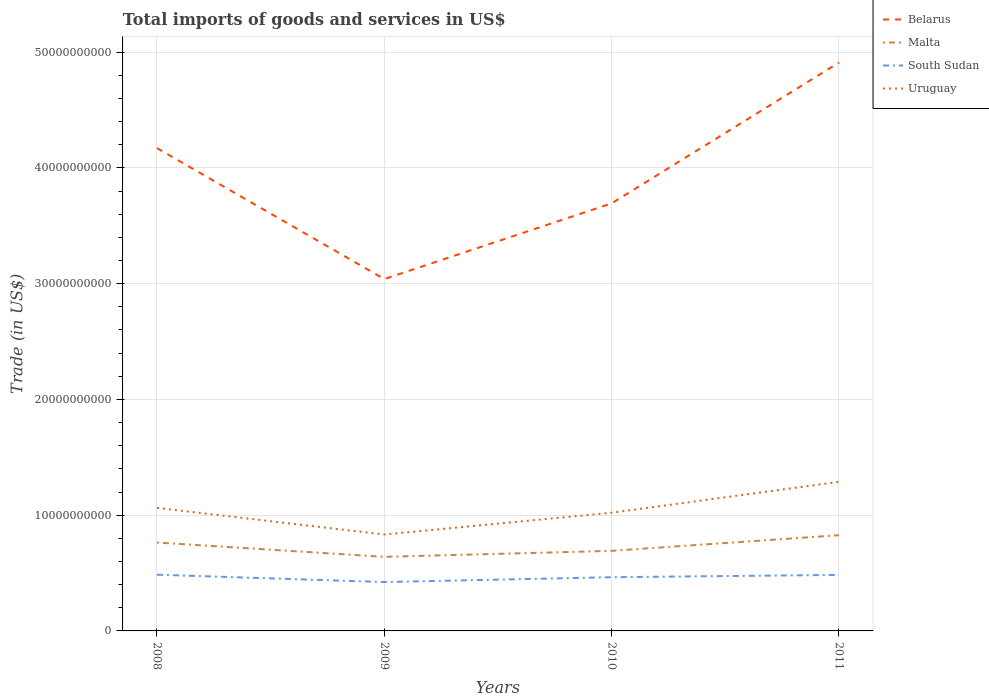How many different coloured lines are there?
Provide a short and direct response. 4. Does the line corresponding to South Sudan intersect with the line corresponding to Uruguay?
Your answer should be compact. No. Is the number of lines equal to the number of legend labels?
Keep it short and to the point. Yes. Across all years, what is the maximum total imports of goods and services in South Sudan?
Your response must be concise. 4.22e+09. What is the total total imports of goods and services in Belarus in the graph?
Offer a very short reply. 4.77e+09. What is the difference between the highest and the second highest total imports of goods and services in South Sudan?
Offer a terse response. 6.35e+08. How many years are there in the graph?
Give a very brief answer. 4. Are the values on the major ticks of Y-axis written in scientific E-notation?
Your answer should be very brief. No. Does the graph contain any zero values?
Make the answer very short. No. How many legend labels are there?
Ensure brevity in your answer.  4. What is the title of the graph?
Make the answer very short. Total imports of goods and services in US$. What is the label or title of the X-axis?
Provide a short and direct response. Years. What is the label or title of the Y-axis?
Offer a terse response. Trade (in US$). What is the Trade (in US$) of Belarus in 2008?
Give a very brief answer. 4.17e+1. What is the Trade (in US$) of Malta in 2008?
Ensure brevity in your answer.  7.64e+09. What is the Trade (in US$) in South Sudan in 2008?
Your response must be concise. 4.86e+09. What is the Trade (in US$) in Uruguay in 2008?
Give a very brief answer. 1.06e+1. What is the Trade (in US$) of Belarus in 2009?
Your answer should be very brief. 3.04e+1. What is the Trade (in US$) in Malta in 2009?
Give a very brief answer. 6.40e+09. What is the Trade (in US$) of South Sudan in 2009?
Offer a very short reply. 4.22e+09. What is the Trade (in US$) of Uruguay in 2009?
Your answer should be very brief. 8.33e+09. What is the Trade (in US$) in Belarus in 2010?
Give a very brief answer. 3.69e+1. What is the Trade (in US$) of Malta in 2010?
Your response must be concise. 6.92e+09. What is the Trade (in US$) of South Sudan in 2010?
Your answer should be very brief. 4.64e+09. What is the Trade (in US$) in Uruguay in 2010?
Provide a succinct answer. 1.02e+1. What is the Trade (in US$) of Belarus in 2011?
Provide a succinct answer. 4.91e+1. What is the Trade (in US$) in Malta in 2011?
Offer a terse response. 8.27e+09. What is the Trade (in US$) of South Sudan in 2011?
Provide a succinct answer. 4.84e+09. What is the Trade (in US$) of Uruguay in 2011?
Give a very brief answer. 1.29e+1. Across all years, what is the maximum Trade (in US$) in Belarus?
Offer a terse response. 4.91e+1. Across all years, what is the maximum Trade (in US$) of Malta?
Offer a very short reply. 8.27e+09. Across all years, what is the maximum Trade (in US$) in South Sudan?
Your response must be concise. 4.86e+09. Across all years, what is the maximum Trade (in US$) in Uruguay?
Your response must be concise. 1.29e+1. Across all years, what is the minimum Trade (in US$) of Belarus?
Give a very brief answer. 3.04e+1. Across all years, what is the minimum Trade (in US$) of Malta?
Offer a terse response. 6.40e+09. Across all years, what is the minimum Trade (in US$) of South Sudan?
Offer a terse response. 4.22e+09. Across all years, what is the minimum Trade (in US$) of Uruguay?
Keep it short and to the point. 8.33e+09. What is the total Trade (in US$) of Belarus in the graph?
Offer a terse response. 1.58e+11. What is the total Trade (in US$) in Malta in the graph?
Provide a succinct answer. 2.92e+1. What is the total Trade (in US$) of South Sudan in the graph?
Your answer should be compact. 1.86e+1. What is the total Trade (in US$) of Uruguay in the graph?
Your response must be concise. 4.21e+1. What is the difference between the Trade (in US$) in Belarus in 2008 and that in 2009?
Provide a succinct answer. 1.13e+1. What is the difference between the Trade (in US$) of Malta in 2008 and that in 2009?
Make the answer very short. 1.24e+09. What is the difference between the Trade (in US$) in South Sudan in 2008 and that in 2009?
Your response must be concise. 6.35e+08. What is the difference between the Trade (in US$) in Uruguay in 2008 and that in 2009?
Provide a succinct answer. 2.30e+09. What is the difference between the Trade (in US$) of Belarus in 2008 and that in 2010?
Keep it short and to the point. 4.77e+09. What is the difference between the Trade (in US$) in Malta in 2008 and that in 2010?
Keep it short and to the point. 7.18e+08. What is the difference between the Trade (in US$) in South Sudan in 2008 and that in 2010?
Ensure brevity in your answer.  2.17e+08. What is the difference between the Trade (in US$) in Uruguay in 2008 and that in 2010?
Your answer should be compact. 4.18e+08. What is the difference between the Trade (in US$) of Belarus in 2008 and that in 2011?
Give a very brief answer. -7.39e+09. What is the difference between the Trade (in US$) of Malta in 2008 and that in 2011?
Keep it short and to the point. -6.33e+08. What is the difference between the Trade (in US$) in South Sudan in 2008 and that in 2011?
Offer a terse response. 1.77e+07. What is the difference between the Trade (in US$) in Uruguay in 2008 and that in 2011?
Offer a very short reply. -2.25e+09. What is the difference between the Trade (in US$) in Belarus in 2009 and that in 2010?
Provide a short and direct response. -6.54e+09. What is the difference between the Trade (in US$) of Malta in 2009 and that in 2010?
Offer a terse response. -5.20e+08. What is the difference between the Trade (in US$) in South Sudan in 2009 and that in 2010?
Make the answer very short. -4.19e+08. What is the difference between the Trade (in US$) of Uruguay in 2009 and that in 2010?
Your answer should be compact. -1.88e+09. What is the difference between the Trade (in US$) in Belarus in 2009 and that in 2011?
Provide a short and direct response. -1.87e+1. What is the difference between the Trade (in US$) in Malta in 2009 and that in 2011?
Provide a short and direct response. -1.87e+09. What is the difference between the Trade (in US$) in South Sudan in 2009 and that in 2011?
Your response must be concise. -6.18e+08. What is the difference between the Trade (in US$) of Uruguay in 2009 and that in 2011?
Offer a terse response. -4.55e+09. What is the difference between the Trade (in US$) of Belarus in 2010 and that in 2011?
Offer a very short reply. -1.22e+1. What is the difference between the Trade (in US$) in Malta in 2010 and that in 2011?
Make the answer very short. -1.35e+09. What is the difference between the Trade (in US$) in South Sudan in 2010 and that in 2011?
Provide a short and direct response. -1.99e+08. What is the difference between the Trade (in US$) in Uruguay in 2010 and that in 2011?
Your answer should be very brief. -2.67e+09. What is the difference between the Trade (in US$) of Belarus in 2008 and the Trade (in US$) of Malta in 2009?
Your answer should be very brief. 3.53e+1. What is the difference between the Trade (in US$) of Belarus in 2008 and the Trade (in US$) of South Sudan in 2009?
Your response must be concise. 3.75e+1. What is the difference between the Trade (in US$) of Belarus in 2008 and the Trade (in US$) of Uruguay in 2009?
Make the answer very short. 3.34e+1. What is the difference between the Trade (in US$) in Malta in 2008 and the Trade (in US$) in South Sudan in 2009?
Keep it short and to the point. 3.41e+09. What is the difference between the Trade (in US$) of Malta in 2008 and the Trade (in US$) of Uruguay in 2009?
Provide a short and direct response. -6.92e+08. What is the difference between the Trade (in US$) of South Sudan in 2008 and the Trade (in US$) of Uruguay in 2009?
Provide a succinct answer. -3.47e+09. What is the difference between the Trade (in US$) in Belarus in 2008 and the Trade (in US$) in Malta in 2010?
Ensure brevity in your answer.  3.48e+1. What is the difference between the Trade (in US$) of Belarus in 2008 and the Trade (in US$) of South Sudan in 2010?
Your answer should be very brief. 3.71e+1. What is the difference between the Trade (in US$) in Belarus in 2008 and the Trade (in US$) in Uruguay in 2010?
Keep it short and to the point. 3.15e+1. What is the difference between the Trade (in US$) of Malta in 2008 and the Trade (in US$) of South Sudan in 2010?
Your response must be concise. 3.00e+09. What is the difference between the Trade (in US$) of Malta in 2008 and the Trade (in US$) of Uruguay in 2010?
Ensure brevity in your answer.  -2.57e+09. What is the difference between the Trade (in US$) of South Sudan in 2008 and the Trade (in US$) of Uruguay in 2010?
Your answer should be very brief. -5.35e+09. What is the difference between the Trade (in US$) of Belarus in 2008 and the Trade (in US$) of Malta in 2011?
Provide a succinct answer. 3.34e+1. What is the difference between the Trade (in US$) in Belarus in 2008 and the Trade (in US$) in South Sudan in 2011?
Offer a very short reply. 3.69e+1. What is the difference between the Trade (in US$) in Belarus in 2008 and the Trade (in US$) in Uruguay in 2011?
Make the answer very short. 2.88e+1. What is the difference between the Trade (in US$) in Malta in 2008 and the Trade (in US$) in South Sudan in 2011?
Offer a terse response. 2.80e+09. What is the difference between the Trade (in US$) of Malta in 2008 and the Trade (in US$) of Uruguay in 2011?
Your answer should be compact. -5.24e+09. What is the difference between the Trade (in US$) in South Sudan in 2008 and the Trade (in US$) in Uruguay in 2011?
Provide a succinct answer. -8.02e+09. What is the difference between the Trade (in US$) in Belarus in 2009 and the Trade (in US$) in Malta in 2010?
Provide a succinct answer. 2.35e+1. What is the difference between the Trade (in US$) in Belarus in 2009 and the Trade (in US$) in South Sudan in 2010?
Keep it short and to the point. 2.58e+1. What is the difference between the Trade (in US$) in Belarus in 2009 and the Trade (in US$) in Uruguay in 2010?
Make the answer very short. 2.02e+1. What is the difference between the Trade (in US$) in Malta in 2009 and the Trade (in US$) in South Sudan in 2010?
Your answer should be very brief. 1.76e+09. What is the difference between the Trade (in US$) in Malta in 2009 and the Trade (in US$) in Uruguay in 2010?
Offer a terse response. -3.81e+09. What is the difference between the Trade (in US$) of South Sudan in 2009 and the Trade (in US$) of Uruguay in 2010?
Keep it short and to the point. -5.99e+09. What is the difference between the Trade (in US$) of Belarus in 2009 and the Trade (in US$) of Malta in 2011?
Your answer should be very brief. 2.21e+1. What is the difference between the Trade (in US$) of Belarus in 2009 and the Trade (in US$) of South Sudan in 2011?
Give a very brief answer. 2.56e+1. What is the difference between the Trade (in US$) of Belarus in 2009 and the Trade (in US$) of Uruguay in 2011?
Your answer should be compact. 1.75e+1. What is the difference between the Trade (in US$) in Malta in 2009 and the Trade (in US$) in South Sudan in 2011?
Provide a short and direct response. 1.56e+09. What is the difference between the Trade (in US$) of Malta in 2009 and the Trade (in US$) of Uruguay in 2011?
Your answer should be very brief. -6.48e+09. What is the difference between the Trade (in US$) of South Sudan in 2009 and the Trade (in US$) of Uruguay in 2011?
Offer a very short reply. -8.66e+09. What is the difference between the Trade (in US$) in Belarus in 2010 and the Trade (in US$) in Malta in 2011?
Your answer should be compact. 2.87e+1. What is the difference between the Trade (in US$) of Belarus in 2010 and the Trade (in US$) of South Sudan in 2011?
Your answer should be very brief. 3.21e+1. What is the difference between the Trade (in US$) of Belarus in 2010 and the Trade (in US$) of Uruguay in 2011?
Your answer should be very brief. 2.41e+1. What is the difference between the Trade (in US$) in Malta in 2010 and the Trade (in US$) in South Sudan in 2011?
Provide a succinct answer. 2.08e+09. What is the difference between the Trade (in US$) in Malta in 2010 and the Trade (in US$) in Uruguay in 2011?
Keep it short and to the point. -5.96e+09. What is the difference between the Trade (in US$) of South Sudan in 2010 and the Trade (in US$) of Uruguay in 2011?
Your response must be concise. -8.24e+09. What is the average Trade (in US$) of Belarus per year?
Provide a short and direct response. 3.95e+1. What is the average Trade (in US$) in Malta per year?
Make the answer very short. 7.31e+09. What is the average Trade (in US$) of South Sudan per year?
Provide a short and direct response. 4.64e+09. What is the average Trade (in US$) of Uruguay per year?
Your answer should be very brief. 1.05e+1. In the year 2008, what is the difference between the Trade (in US$) in Belarus and Trade (in US$) in Malta?
Make the answer very short. 3.41e+1. In the year 2008, what is the difference between the Trade (in US$) of Belarus and Trade (in US$) of South Sudan?
Make the answer very short. 3.69e+1. In the year 2008, what is the difference between the Trade (in US$) of Belarus and Trade (in US$) of Uruguay?
Provide a succinct answer. 3.11e+1. In the year 2008, what is the difference between the Trade (in US$) of Malta and Trade (in US$) of South Sudan?
Give a very brief answer. 2.78e+09. In the year 2008, what is the difference between the Trade (in US$) of Malta and Trade (in US$) of Uruguay?
Ensure brevity in your answer.  -2.99e+09. In the year 2008, what is the difference between the Trade (in US$) in South Sudan and Trade (in US$) in Uruguay?
Your answer should be very brief. -5.77e+09. In the year 2009, what is the difference between the Trade (in US$) in Belarus and Trade (in US$) in Malta?
Your response must be concise. 2.40e+1. In the year 2009, what is the difference between the Trade (in US$) in Belarus and Trade (in US$) in South Sudan?
Give a very brief answer. 2.62e+1. In the year 2009, what is the difference between the Trade (in US$) of Belarus and Trade (in US$) of Uruguay?
Provide a short and direct response. 2.21e+1. In the year 2009, what is the difference between the Trade (in US$) of Malta and Trade (in US$) of South Sudan?
Provide a succinct answer. 2.18e+09. In the year 2009, what is the difference between the Trade (in US$) in Malta and Trade (in US$) in Uruguay?
Your answer should be compact. -1.93e+09. In the year 2009, what is the difference between the Trade (in US$) of South Sudan and Trade (in US$) of Uruguay?
Your answer should be compact. -4.11e+09. In the year 2010, what is the difference between the Trade (in US$) in Belarus and Trade (in US$) in Malta?
Your response must be concise. 3.00e+1. In the year 2010, what is the difference between the Trade (in US$) of Belarus and Trade (in US$) of South Sudan?
Ensure brevity in your answer.  3.23e+1. In the year 2010, what is the difference between the Trade (in US$) of Belarus and Trade (in US$) of Uruguay?
Your answer should be very brief. 2.67e+1. In the year 2010, what is the difference between the Trade (in US$) of Malta and Trade (in US$) of South Sudan?
Your answer should be very brief. 2.28e+09. In the year 2010, what is the difference between the Trade (in US$) in Malta and Trade (in US$) in Uruguay?
Ensure brevity in your answer.  -3.29e+09. In the year 2010, what is the difference between the Trade (in US$) in South Sudan and Trade (in US$) in Uruguay?
Offer a terse response. -5.57e+09. In the year 2011, what is the difference between the Trade (in US$) of Belarus and Trade (in US$) of Malta?
Your answer should be very brief. 4.08e+1. In the year 2011, what is the difference between the Trade (in US$) of Belarus and Trade (in US$) of South Sudan?
Make the answer very short. 4.43e+1. In the year 2011, what is the difference between the Trade (in US$) in Belarus and Trade (in US$) in Uruguay?
Offer a very short reply. 3.62e+1. In the year 2011, what is the difference between the Trade (in US$) in Malta and Trade (in US$) in South Sudan?
Provide a short and direct response. 3.43e+09. In the year 2011, what is the difference between the Trade (in US$) in Malta and Trade (in US$) in Uruguay?
Your response must be concise. -4.61e+09. In the year 2011, what is the difference between the Trade (in US$) in South Sudan and Trade (in US$) in Uruguay?
Keep it short and to the point. -8.04e+09. What is the ratio of the Trade (in US$) of Belarus in 2008 to that in 2009?
Provide a short and direct response. 1.37. What is the ratio of the Trade (in US$) in Malta in 2008 to that in 2009?
Your answer should be compact. 1.19. What is the ratio of the Trade (in US$) in South Sudan in 2008 to that in 2009?
Give a very brief answer. 1.15. What is the ratio of the Trade (in US$) in Uruguay in 2008 to that in 2009?
Your response must be concise. 1.28. What is the ratio of the Trade (in US$) of Belarus in 2008 to that in 2010?
Provide a short and direct response. 1.13. What is the ratio of the Trade (in US$) of Malta in 2008 to that in 2010?
Your answer should be compact. 1.1. What is the ratio of the Trade (in US$) of South Sudan in 2008 to that in 2010?
Keep it short and to the point. 1.05. What is the ratio of the Trade (in US$) in Uruguay in 2008 to that in 2010?
Keep it short and to the point. 1.04. What is the ratio of the Trade (in US$) of Belarus in 2008 to that in 2011?
Provide a short and direct response. 0.85. What is the ratio of the Trade (in US$) in Malta in 2008 to that in 2011?
Provide a succinct answer. 0.92. What is the ratio of the Trade (in US$) of South Sudan in 2008 to that in 2011?
Offer a very short reply. 1. What is the ratio of the Trade (in US$) of Uruguay in 2008 to that in 2011?
Give a very brief answer. 0.83. What is the ratio of the Trade (in US$) in Belarus in 2009 to that in 2010?
Offer a terse response. 0.82. What is the ratio of the Trade (in US$) in Malta in 2009 to that in 2010?
Offer a terse response. 0.92. What is the ratio of the Trade (in US$) in South Sudan in 2009 to that in 2010?
Provide a short and direct response. 0.91. What is the ratio of the Trade (in US$) of Uruguay in 2009 to that in 2010?
Make the answer very short. 0.82. What is the ratio of the Trade (in US$) in Belarus in 2009 to that in 2011?
Offer a very short reply. 0.62. What is the ratio of the Trade (in US$) of Malta in 2009 to that in 2011?
Ensure brevity in your answer.  0.77. What is the ratio of the Trade (in US$) of South Sudan in 2009 to that in 2011?
Make the answer very short. 0.87. What is the ratio of the Trade (in US$) of Uruguay in 2009 to that in 2011?
Offer a terse response. 0.65. What is the ratio of the Trade (in US$) in Belarus in 2010 to that in 2011?
Make the answer very short. 0.75. What is the ratio of the Trade (in US$) of Malta in 2010 to that in 2011?
Ensure brevity in your answer.  0.84. What is the ratio of the Trade (in US$) of South Sudan in 2010 to that in 2011?
Your answer should be compact. 0.96. What is the ratio of the Trade (in US$) of Uruguay in 2010 to that in 2011?
Offer a terse response. 0.79. What is the difference between the highest and the second highest Trade (in US$) in Belarus?
Provide a short and direct response. 7.39e+09. What is the difference between the highest and the second highest Trade (in US$) of Malta?
Ensure brevity in your answer.  6.33e+08. What is the difference between the highest and the second highest Trade (in US$) of South Sudan?
Your answer should be very brief. 1.77e+07. What is the difference between the highest and the second highest Trade (in US$) of Uruguay?
Offer a terse response. 2.25e+09. What is the difference between the highest and the lowest Trade (in US$) of Belarus?
Offer a very short reply. 1.87e+1. What is the difference between the highest and the lowest Trade (in US$) of Malta?
Offer a terse response. 1.87e+09. What is the difference between the highest and the lowest Trade (in US$) in South Sudan?
Keep it short and to the point. 6.35e+08. What is the difference between the highest and the lowest Trade (in US$) of Uruguay?
Ensure brevity in your answer.  4.55e+09. 